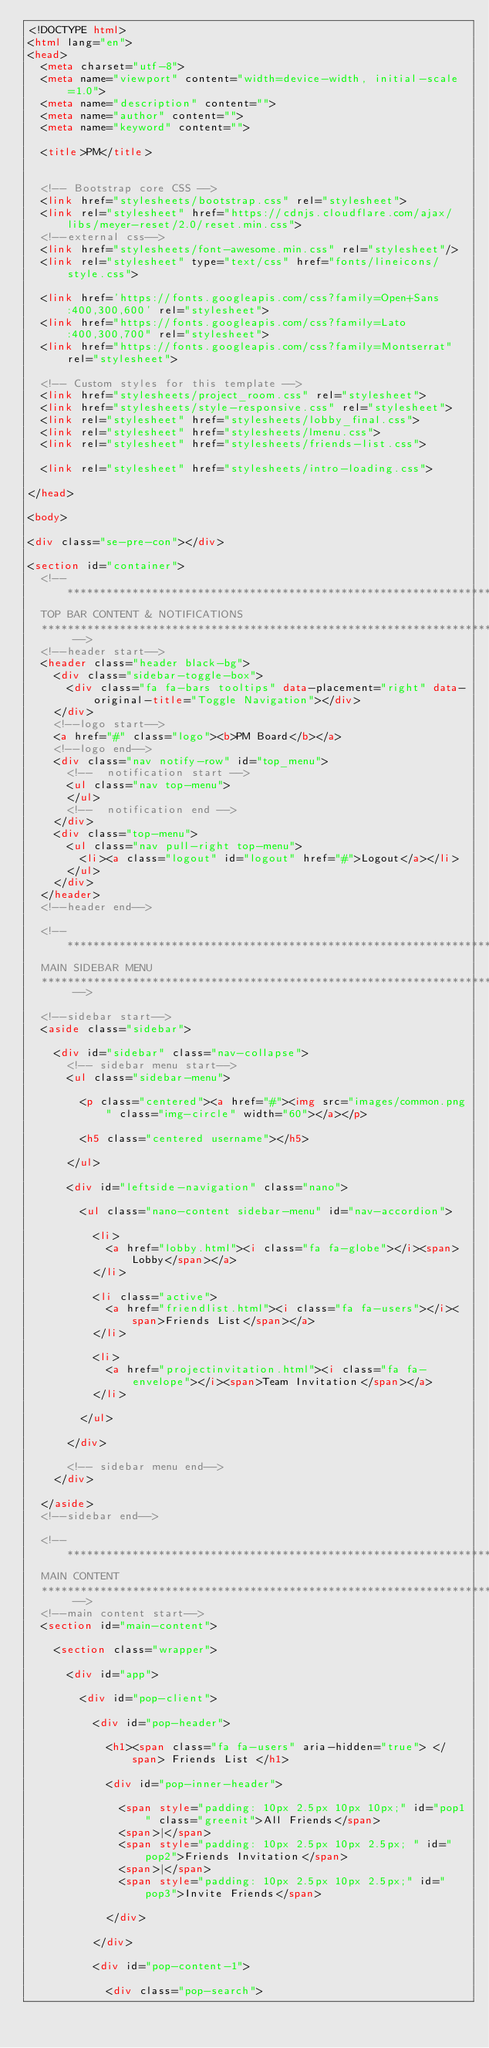<code> <loc_0><loc_0><loc_500><loc_500><_HTML_><!DOCTYPE html>
<html lang="en">
<head>
  <meta charset="utf-8">
  <meta name="viewport" content="width=device-width, initial-scale=1.0">
  <meta name="description" content="">
  <meta name="author" content="">
  <meta name="keyword" content="">

  <title>PM</title>


  <!-- Bootstrap core CSS -->
  <link href="stylesheets/bootstrap.css" rel="stylesheet">
  <link rel="stylesheet" href="https://cdnjs.cloudflare.com/ajax/libs/meyer-reset/2.0/reset.min.css">
  <!--external css-->
  <link href="stylesheets/font-awesome.min.css" rel="stylesheet"/>
  <link rel="stylesheet" type="text/css" href="fonts/lineicons/style.css">

  <link href='https://fonts.googleapis.com/css?family=Open+Sans:400,300,600' rel="stylesheet">
  <link href="https://fonts.googleapis.com/css?family=Lato:400,300,700" rel="stylesheet">
  <link href="https://fonts.googleapis.com/css?family=Montserrat" rel="stylesheet">

  <!-- Custom styles for this template -->
  <link href="stylesheets/project_room.css" rel="stylesheet">
  <link href="stylesheets/style-responsive.css" rel="stylesheet">
  <link rel="stylesheet" href="stylesheets/lobby_final.css">
  <link rel="stylesheet" href="stylesheets/lmenu.css">
  <link rel="stylesheet" href="stylesheets/friends-list.css">

  <link rel="stylesheet" href="stylesheets/intro-loading.css">

</head>

<body>

<div class="se-pre-con"></div>

<section id="container">
  <!-- **********************************************************************************************************************************************************
  TOP BAR CONTENT & NOTIFICATIONS
  *********************************************************************************************************************************************************** -->
  <!--header start-->
  <header class="header black-bg">
    <div class="sidebar-toggle-box">
      <div class="fa fa-bars tooltips" data-placement="right" data-original-title="Toggle Navigation"></div>
    </div>
    <!--logo start-->
    <a href="#" class="logo"><b>PM Board</b></a>
    <!--logo end-->
    <div class="nav notify-row" id="top_menu">
      <!--  notification start -->
      <ul class="nav top-menu">
      </ul>
      <!--  notification end -->
    </div>
    <div class="top-menu">
      <ul class="nav pull-right top-menu">
        <li><a class="logout" id="logout" href="#">Logout</a></li>
      </ul>
    </div>
  </header>
  <!--header end-->

  <!-- **********************************************************************************************************************************************************
  MAIN SIDEBAR MENU
  *********************************************************************************************************************************************************** -->

  <!--sidebar start-->
  <aside class="sidebar">

    <div id="sidebar" class="nav-collapse">
      <!-- sidebar menu start-->
      <ul class="sidebar-menu">

        <p class="centered"><a href="#"><img src="images/common.png" class="img-circle" width="60"></a></p>

        <h5 class="centered username"></h5>

      </ul>

      <div id="leftside-navigation" class="nano">

        <ul class="nano-content sidebar-menu" id="nav-accordion">

          <li>
            <a href="lobby.html"><i class="fa fa-globe"></i><span>Lobby</span></a>
          </li>

          <li class="active">
            <a href="friendlist.html"><i class="fa fa-users"></i><span>Friends List</span></a>
          </li>

          <li>
            <a href="projectinvitation.html"><i class="fa fa-envelope"></i><span>Team Invitation</span></a>
          </li>

        </ul>

      </div>

      <!-- sidebar menu end-->
    </div>

  </aside>
  <!--sidebar end-->

  <!-- **********************************************************************************************************************************************************
  MAIN CONTENT
  *********************************************************************************************************************************************************** -->
  <!--main content start-->
  <section id="main-content">

    <section class="wrapper">

      <div id="app">

        <div id="pop-client">

          <div id="pop-header">

            <h1><span class="fa fa-users" aria-hidden="true"> </span> Friends List </h1>

            <div id="pop-inner-header">

              <span style="padding: 10px 2.5px 10px 10px;" id="pop1" class="greenit">All Friends</span>
              <span>|</span>
              <span style="padding: 10px 2.5px 10px 2.5px; " id="pop2">Friends Invitation</span>
              <span>|</span>
              <span style="padding: 10px 2.5px 10px 2.5px;" id="pop3">Invite Friends</span>

            </div>

          </div>

          <div id="pop-content-1">

            <div class="pop-search"></code> 